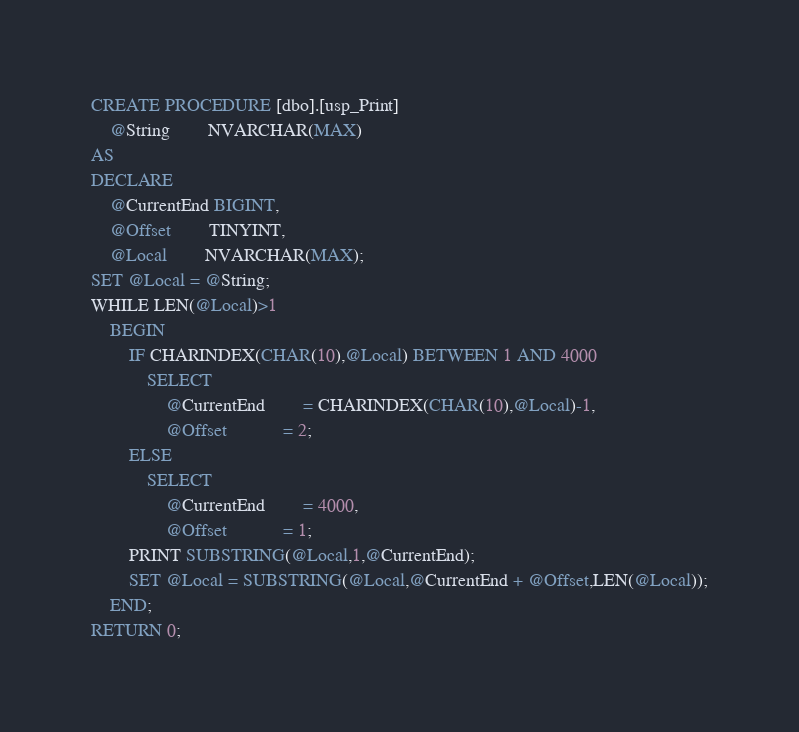<code> <loc_0><loc_0><loc_500><loc_500><_SQL_>CREATE PROCEDURE [dbo].[usp_Print]
	@String		NVARCHAR(MAX)
AS
DECLARE
	@CurrentEnd BIGINT,
	@Offset		TINYINT,
	@Local		NVARCHAR(MAX);
SET @Local = @String;
WHILE LEN(@Local)>1
	BEGIN
		IF CHARINDEX(CHAR(10),@Local) BETWEEN 1 AND 4000
			SELECT
				@CurrentEnd		= CHARINDEX(CHAR(10),@Local)-1,
				@Offset			= 2;
		ELSE
			SELECT
				@CurrentEnd		= 4000,
				@Offset			= 1;
		PRINT SUBSTRING(@Local,1,@CurrentEnd);
		SET @Local = SUBSTRING(@Local,@CurrentEnd + @Offset,LEN(@Local));
	END;
RETURN 0;
</code> 